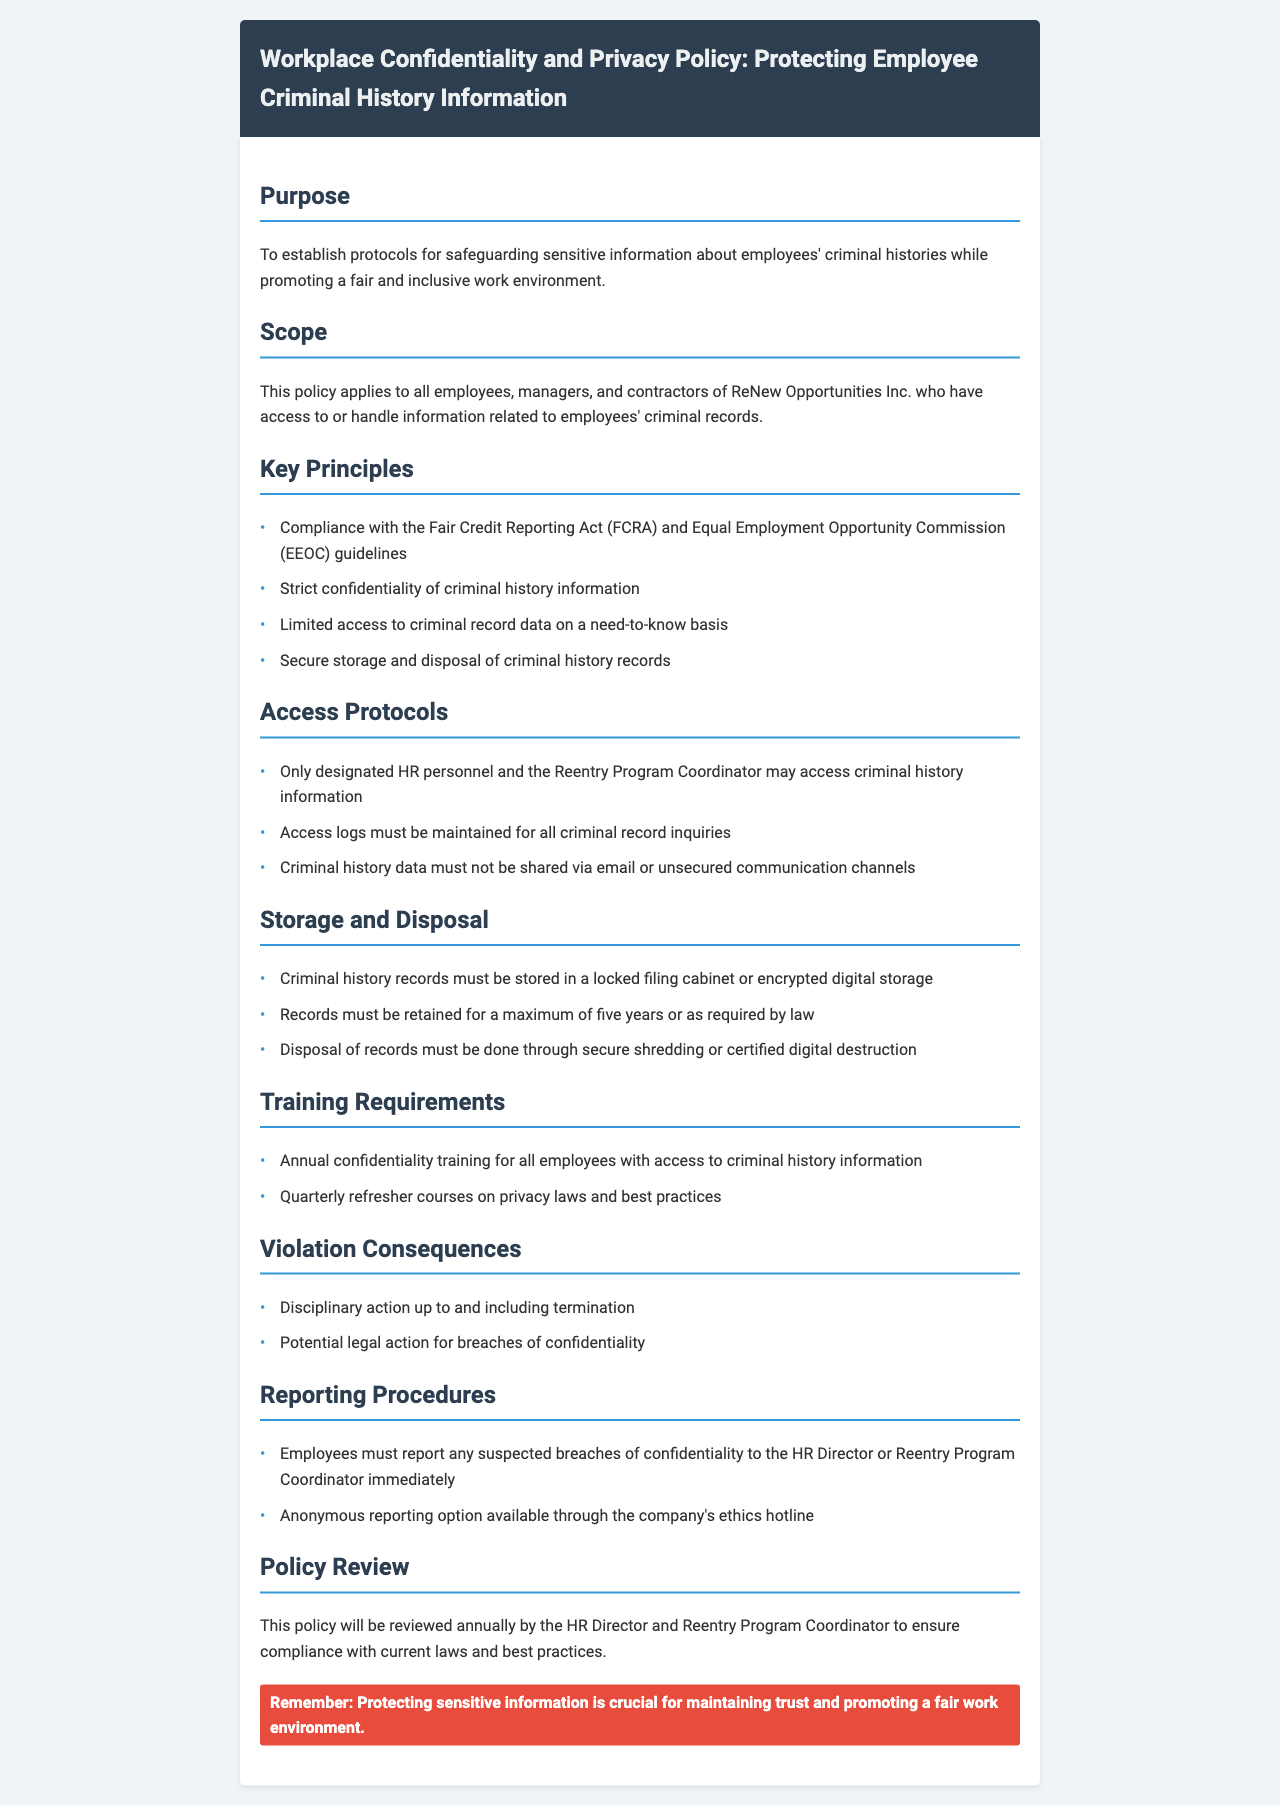What is the purpose of the policy? The policy's purpose is to establish protocols for safeguarding sensitive information about employees' criminal histories while promoting a fair and inclusive work environment.
Answer: Safeguarding sensitive information What document does this policy comply with? The policy mentions compliance with the Fair Credit Reporting Act (FCRA) and the Equal Employment Opportunity Commission (EEOC) guidelines.
Answer: Fair Credit Reporting Act Who can access criminal history information? The policy states that only designated HR personnel and the Reentry Program Coordinator may access criminal history information.
Answer: Designated HR personnel and Reentry Program Coordinator How long must criminal history records be retained? The document specifies that criminal history records must be retained for a maximum of five years or as required by law.
Answer: Five years What training is required for employees? The policy mandates annual confidentiality training for all employees with access to criminal history information.
Answer: Annual confidentiality training What actions are potential consequences for a policy violation? The document lists disciplinary action up to and including termination, and potential legal action for breaches of confidentiality as consequences.
Answer: Termination What is the policy review frequency? The policy states it will be reviewed annually by the HR Director and Reentry Program Coordinator.
Answer: Annually What should employees do if they suspect a breach of confidentiality? The document instructs employees to report any suspected breaches of confidentiality to the HR Director or Reentry Program Coordinator immediately.
Answer: Report to HR Director or Reentry Program Coordinator 